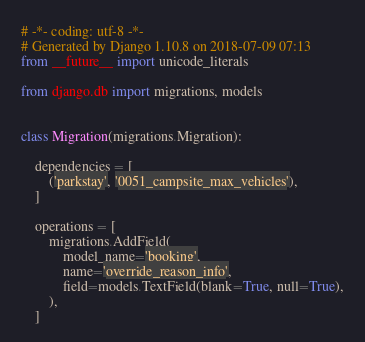<code> <loc_0><loc_0><loc_500><loc_500><_Python_># -*- coding: utf-8 -*-
# Generated by Django 1.10.8 on 2018-07-09 07:13
from __future__ import unicode_literals

from django.db import migrations, models


class Migration(migrations.Migration):

    dependencies = [
        ('parkstay', '0051_campsite_max_vehicles'),
    ]

    operations = [
        migrations.AddField(
            model_name='booking',
            name='override_reason_info',
            field=models.TextField(blank=True, null=True),
        ),
    ]
</code> 